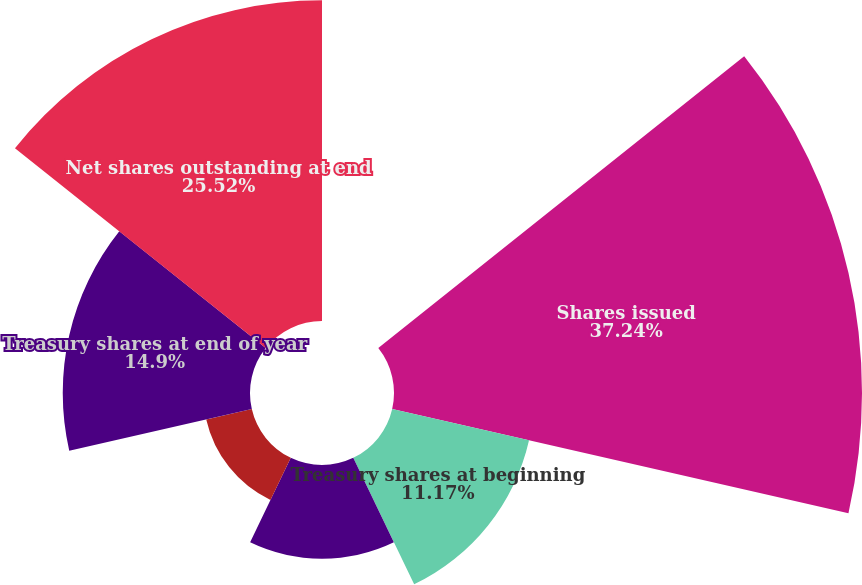Convert chart. <chart><loc_0><loc_0><loc_500><loc_500><pie_chart><fcel>For the years ended December<fcel>Shares issued<fcel>Treasury shares at beginning<fcel>Repurchase programs and<fcel>Stock options and benefits<fcel>Treasury shares at end of year<fcel>Net shares outstanding at end<nl><fcel>0.0%<fcel>37.24%<fcel>11.17%<fcel>7.45%<fcel>3.72%<fcel>14.9%<fcel>25.52%<nl></chart> 